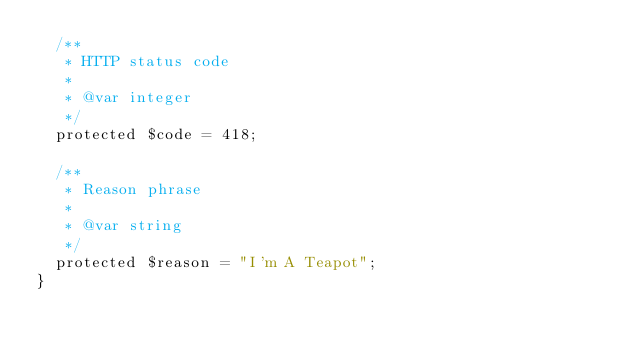<code> <loc_0><loc_0><loc_500><loc_500><_PHP_>	/**
	 * HTTP status code
	 *
	 * @var integer
	 */
	protected $code = 418;

	/**
	 * Reason phrase
	 *
	 * @var string
	 */
	protected $reason = "I'm A Teapot";
}</code> 